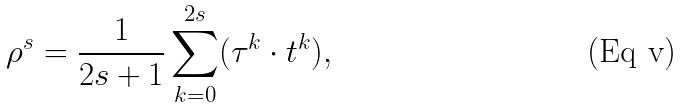<formula> <loc_0><loc_0><loc_500><loc_500>\rho ^ { s } = \frac { 1 } { 2 s + 1 } \sum _ { k = 0 } ^ { 2 s } ( \tau ^ { k } \cdot t ^ { k } ) ,</formula> 